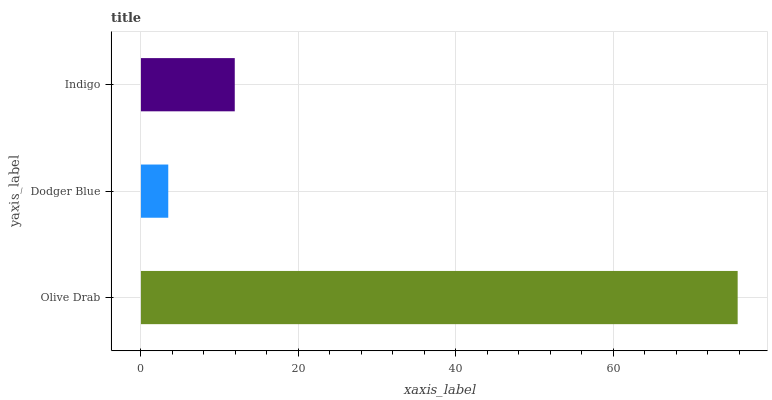Is Dodger Blue the minimum?
Answer yes or no. Yes. Is Olive Drab the maximum?
Answer yes or no. Yes. Is Indigo the minimum?
Answer yes or no. No. Is Indigo the maximum?
Answer yes or no. No. Is Indigo greater than Dodger Blue?
Answer yes or no. Yes. Is Dodger Blue less than Indigo?
Answer yes or no. Yes. Is Dodger Blue greater than Indigo?
Answer yes or no. No. Is Indigo less than Dodger Blue?
Answer yes or no. No. Is Indigo the high median?
Answer yes or no. Yes. Is Indigo the low median?
Answer yes or no. Yes. Is Dodger Blue the high median?
Answer yes or no. No. Is Dodger Blue the low median?
Answer yes or no. No. 